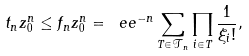Convert formula to latex. <formula><loc_0><loc_0><loc_500><loc_500>t _ { n } z _ { 0 } ^ { n } \leq f _ { n } z _ { 0 } ^ { n } = \ e e ^ { - n } \sum _ { T \in { \mathcal { T } } _ { n } } \prod _ { i \in T } \frac { 1 } { \xi _ { i } ! } ,</formula> 